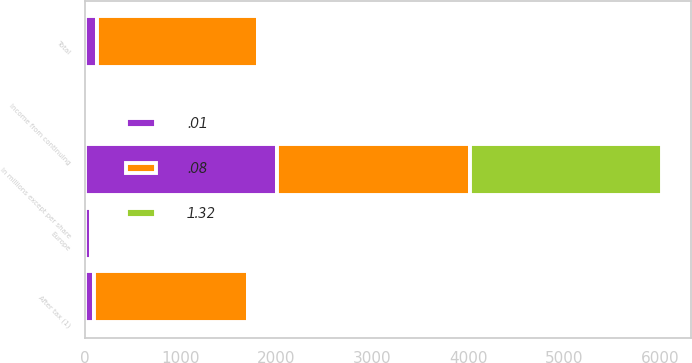<chart> <loc_0><loc_0><loc_500><loc_500><stacked_bar_chart><ecel><fcel>In millions except per share<fcel>Europe<fcel>Total<fcel>After tax (1)<fcel>Income from continuing<nl><fcel>1.32<fcel>2008<fcel>6<fcel>6<fcel>4<fcel>0.01<nl><fcel>0.08<fcel>2007<fcel>11<fcel>1670<fcel>1606<fcel>1.32<nl><fcel>0.01<fcel>2006<fcel>62<fcel>134<fcel>98<fcel>0.08<nl></chart> 